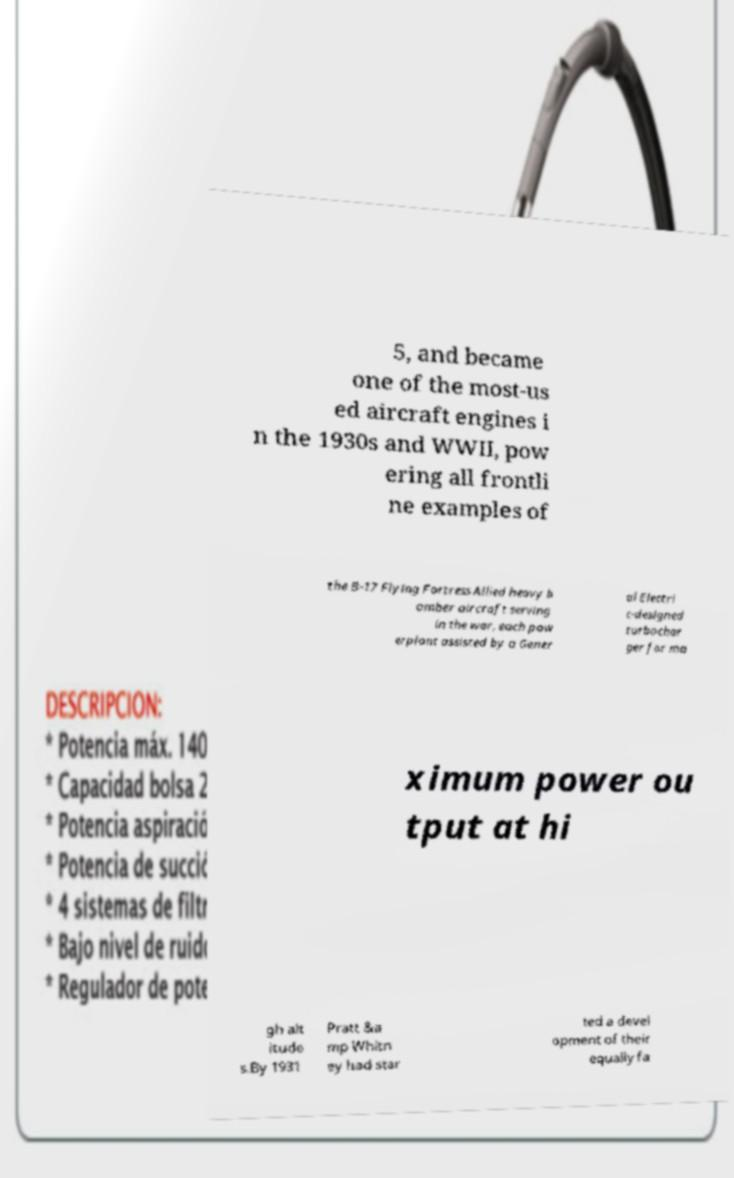Could you extract and type out the text from this image? 5, and became one of the most-us ed aircraft engines i n the 1930s and WWII, pow ering all frontli ne examples of the B-17 Flying Fortress Allied heavy b omber aircraft serving in the war, each pow erplant assisted by a Gener al Electri c-designed turbochar ger for ma ximum power ou tput at hi gh alt itude s.By 1931 Pratt &a mp Whitn ey had star ted a devel opment of their equally fa 